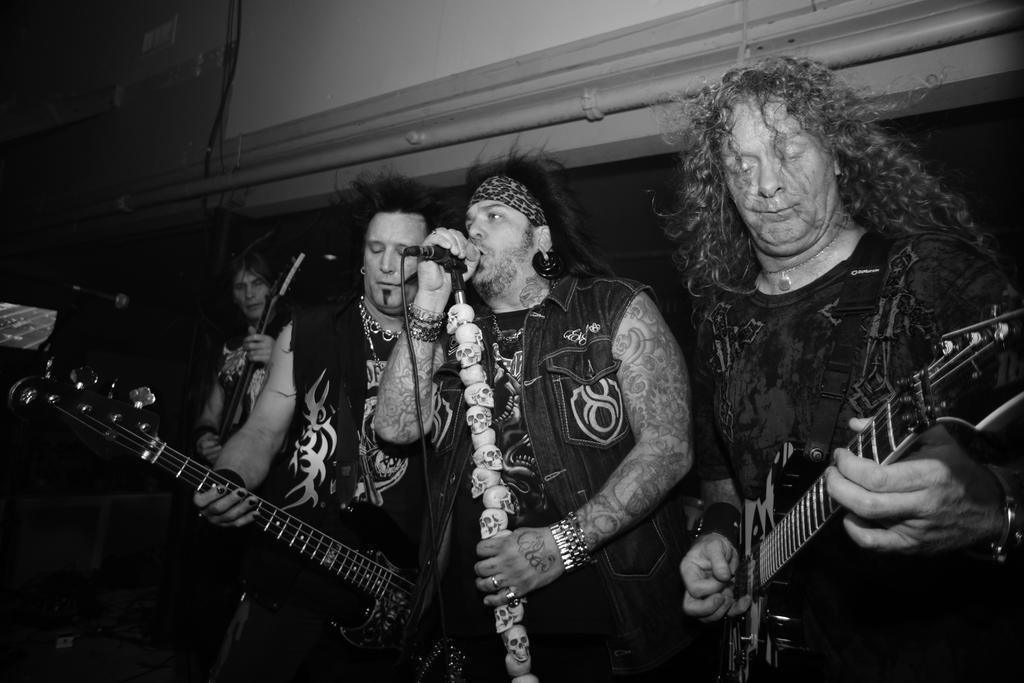In one or two sentences, can you explain what this image depicts? There are four persons standing. In the right end a person is holding guitar and playing. Next to him a person is holding mic. on the mic stand there are skull heads and he is singing. Next to him a person is playing guitar and playing. Back also person is playing a guitar. And there is a mic stand. In the background there is a wall with pipe. 